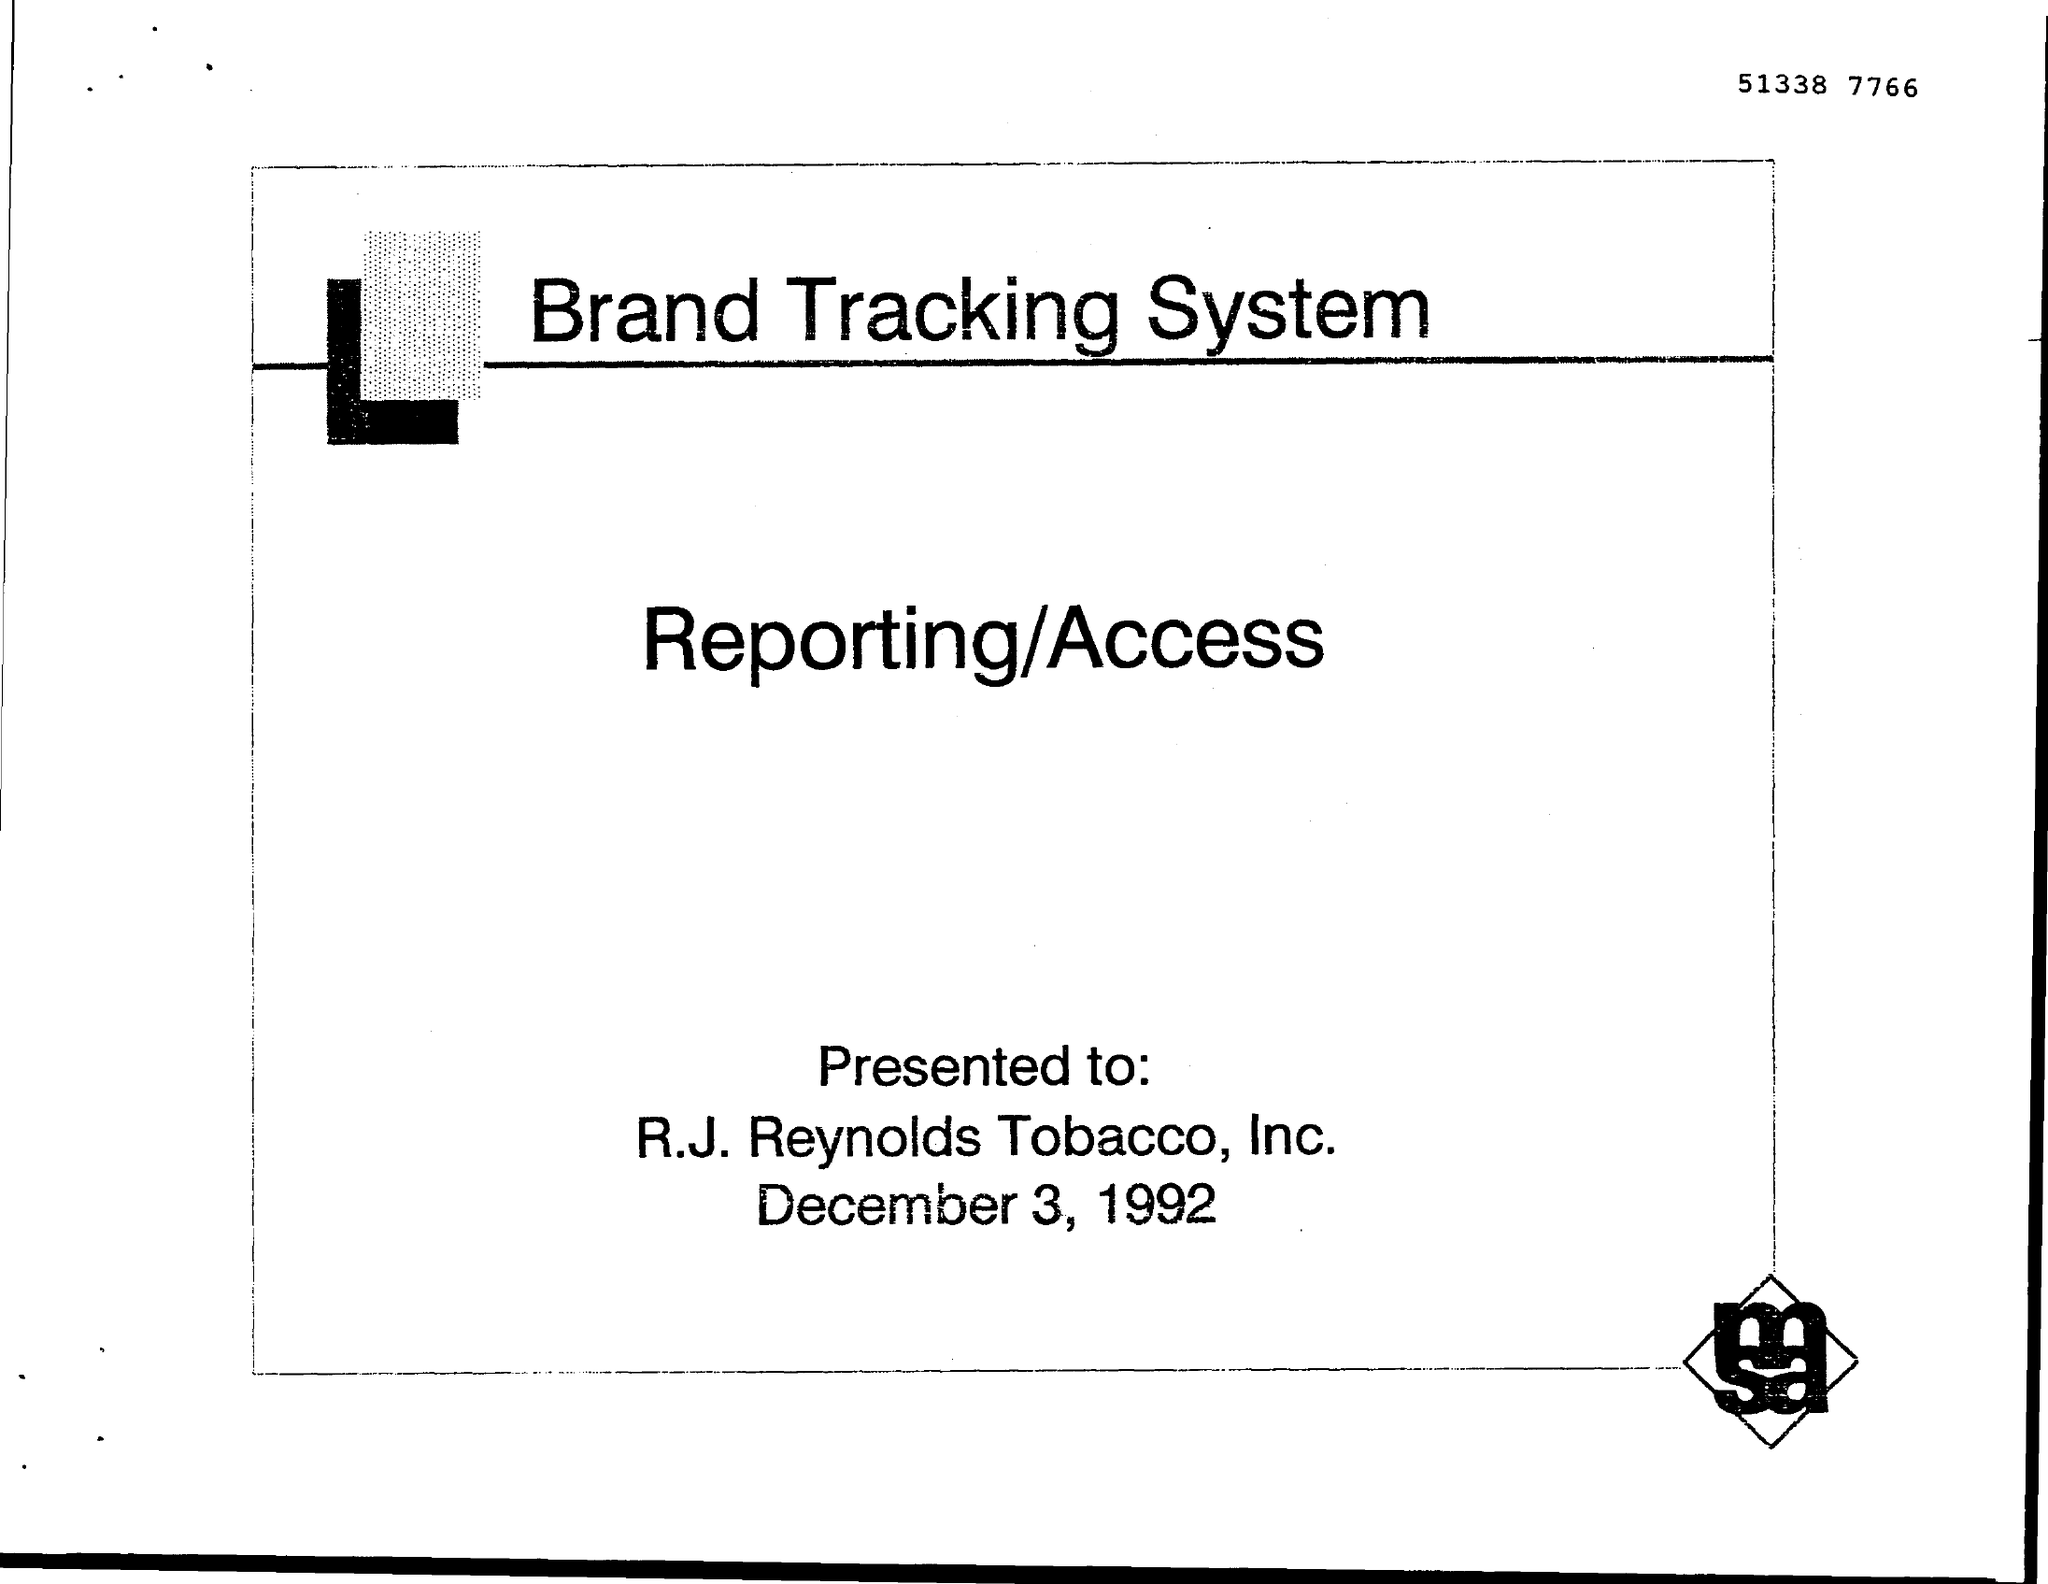Indicate a few pertinent items in this graphic. The document is titled "Brand Tracking System. The recipient of this presentation is R. J. Reynolds tobacco, Inc.. The document number is 51338 7766. On December 3, 1992, the date is known. 